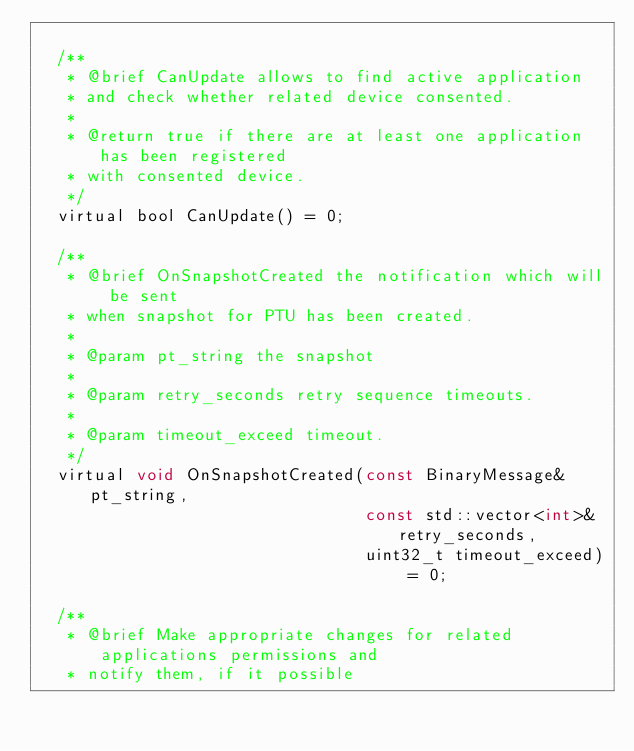Convert code to text. <code><loc_0><loc_0><loc_500><loc_500><_C_>
  /**
   * @brief CanUpdate allows to find active application
   * and check whether related device consented.
   *
   * @return true if there are at least one application has been registered
   * with consented device.
   */
  virtual bool CanUpdate() = 0;

  /**
   * @brief OnSnapshotCreated the notification which will be sent
   * when snapshot for PTU has been created.
   *
   * @param pt_string the snapshot
   *
   * @param retry_seconds retry sequence timeouts.
   *
   * @param timeout_exceed timeout.
   */
  virtual void OnSnapshotCreated(const BinaryMessage& pt_string,
                                 const std::vector<int>& retry_seconds,
                                 uint32_t timeout_exceed) = 0;

  /**
   * @brief Make appropriate changes for related applications permissions and
   * notify them, if it possible</code> 